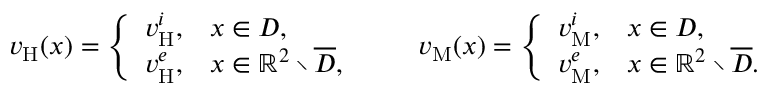<formula> <loc_0><loc_0><loc_500><loc_500>\begin{array} { r } { v _ { H } ( x ) = \left \{ \begin{array} { l l } { v _ { H } ^ { i } , } & { x \in D , } \\ { v _ { H } ^ { e } , } & { x \in \mathbb { R } ^ { 2 } \ \overline { D } , } \end{array} \quad v _ { M } ( x ) = \left \{ \begin{array} { l l } { v _ { M } ^ { i } , } & { x \in D , } \\ { v _ { M } ^ { e } , } & { x \in \mathbb { R } ^ { 2 } \ \overline { D } . } \end{array} } \end{array}</formula> 